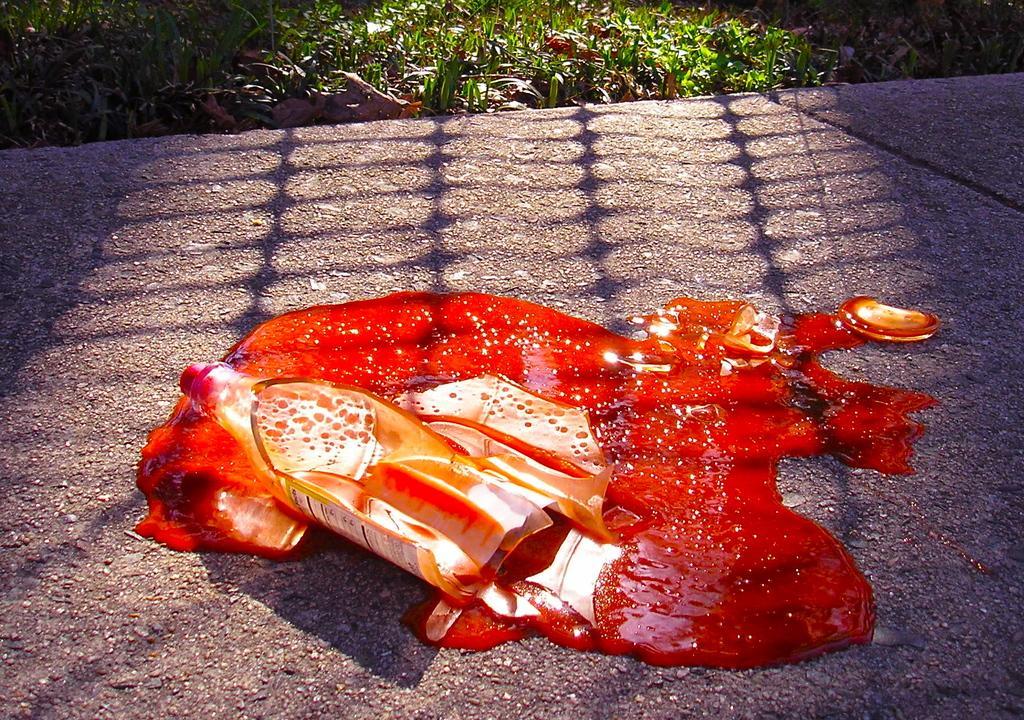In one or two sentences, can you explain what this image depicts? In the center of the image we can see a bottle broken on the road. We can see a liquid. In the background there is grass. 